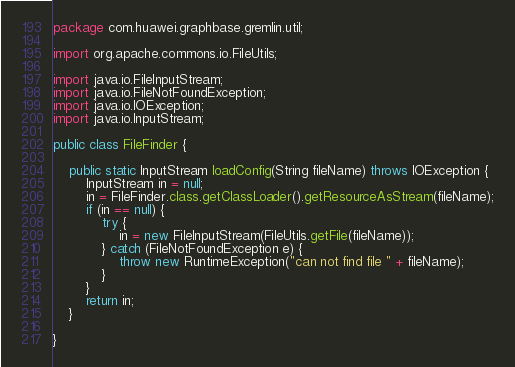Convert code to text. <code><loc_0><loc_0><loc_500><loc_500><_Java_>package com.huawei.graphbase.gremlin.util;

import org.apache.commons.io.FileUtils;

import java.io.FileInputStream;
import java.io.FileNotFoundException;
import java.io.IOException;
import java.io.InputStream;

public class FileFinder {

    public static InputStream loadConfig(String fileName) throws IOException {
        InputStream in = null;
        in = FileFinder.class.getClassLoader().getResourceAsStream(fileName);
        if (in == null) {
            try {
                in = new FileInputStream(FileUtils.getFile(fileName));
            } catch (FileNotFoundException e) {
                throw new RuntimeException("can not find file " + fileName);
            }
        }
        return in;
    }

}
</code> 